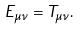Convert formula to latex. <formula><loc_0><loc_0><loc_500><loc_500>E _ { \mu \nu } = T _ { \mu \nu } .</formula> 